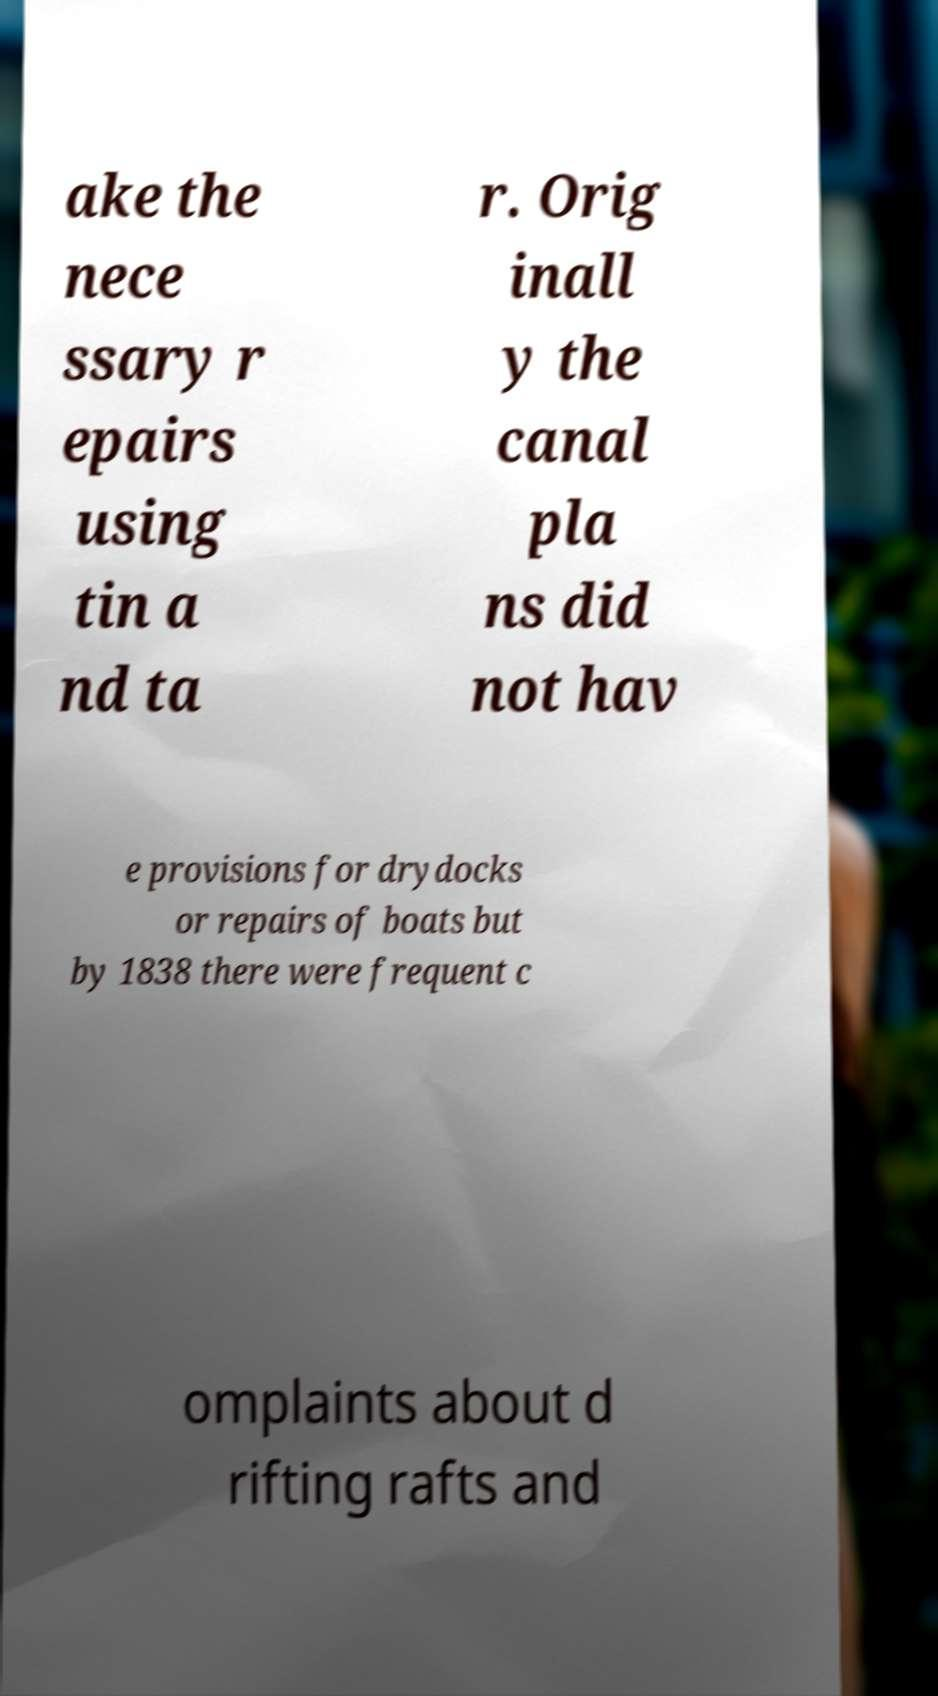Can you accurately transcribe the text from the provided image for me? ake the nece ssary r epairs using tin a nd ta r. Orig inall y the canal pla ns did not hav e provisions for drydocks or repairs of boats but by 1838 there were frequent c omplaints about d rifting rafts and 